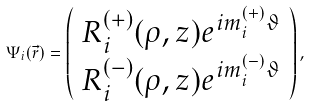<formula> <loc_0><loc_0><loc_500><loc_500>\Psi _ { i } ( \vec { r } ) = \left ( \begin{array} { c } { R _ { i } ^ { ( + ) } ( \rho , z ) e ^ { i m _ { i } ^ { ( + ) } \vartheta } } \\ { R _ { i } ^ { ( - ) } ( \rho , z ) e ^ { i m _ { i } ^ { ( - ) } \vartheta } } \end{array} \right ) ,</formula> 